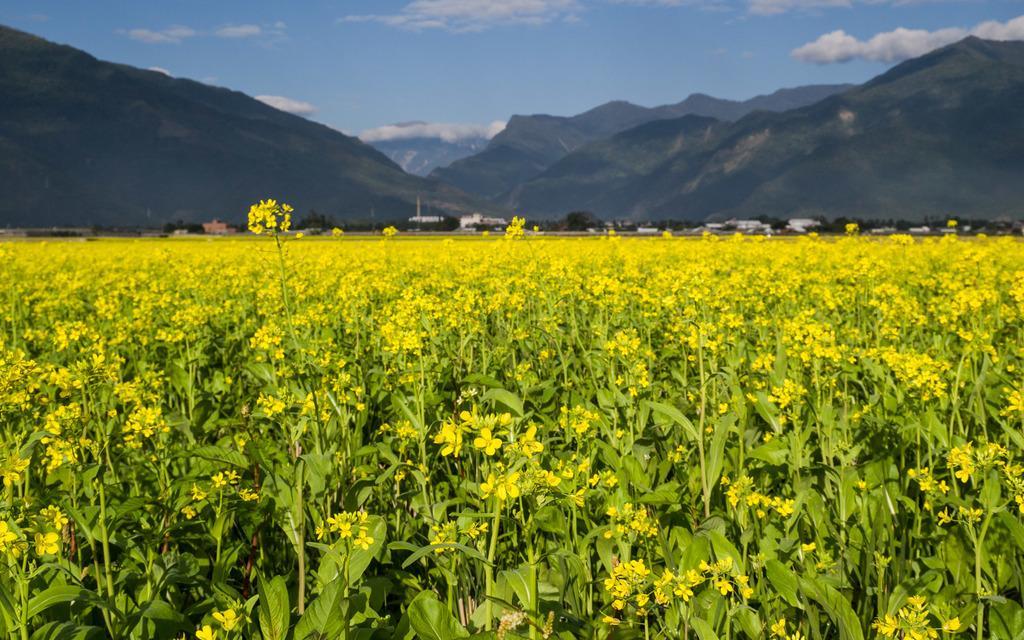In one or two sentences, can you explain what this image depicts? In the picture I can see flower plants. These flowers are yellow in color. In the background I can see mountains, buildings, trees and the sky. 